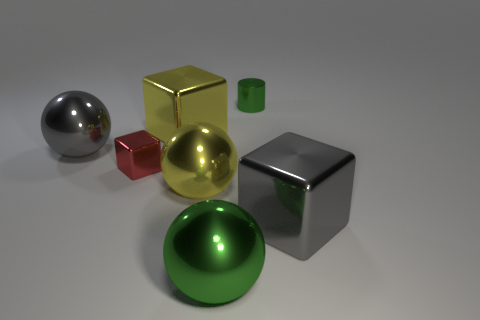Is there anything else that has the same shape as the small green thing?
Offer a very short reply. No. How big is the green cylinder?
Provide a short and direct response. Small. What is the color of the other small block that is made of the same material as the yellow cube?
Provide a succinct answer. Red. How many other blocks have the same size as the red block?
Give a very brief answer. 0. Is the material of the green thing behind the green sphere the same as the green ball?
Offer a very short reply. Yes. Is the number of tiny red things in front of the tiny metal cylinder less than the number of tiny green rubber cylinders?
Provide a short and direct response. No. There is a big gray shiny object on the left side of the red object; what shape is it?
Keep it short and to the point. Sphere. There is a shiny thing that is the same size as the red cube; what is its shape?
Give a very brief answer. Cylinder. Is there another tiny thing that has the same shape as the tiny red object?
Make the answer very short. No. Do the big gray thing that is behind the gray block and the big thing on the right side of the big green metallic sphere have the same shape?
Provide a succinct answer. No. 